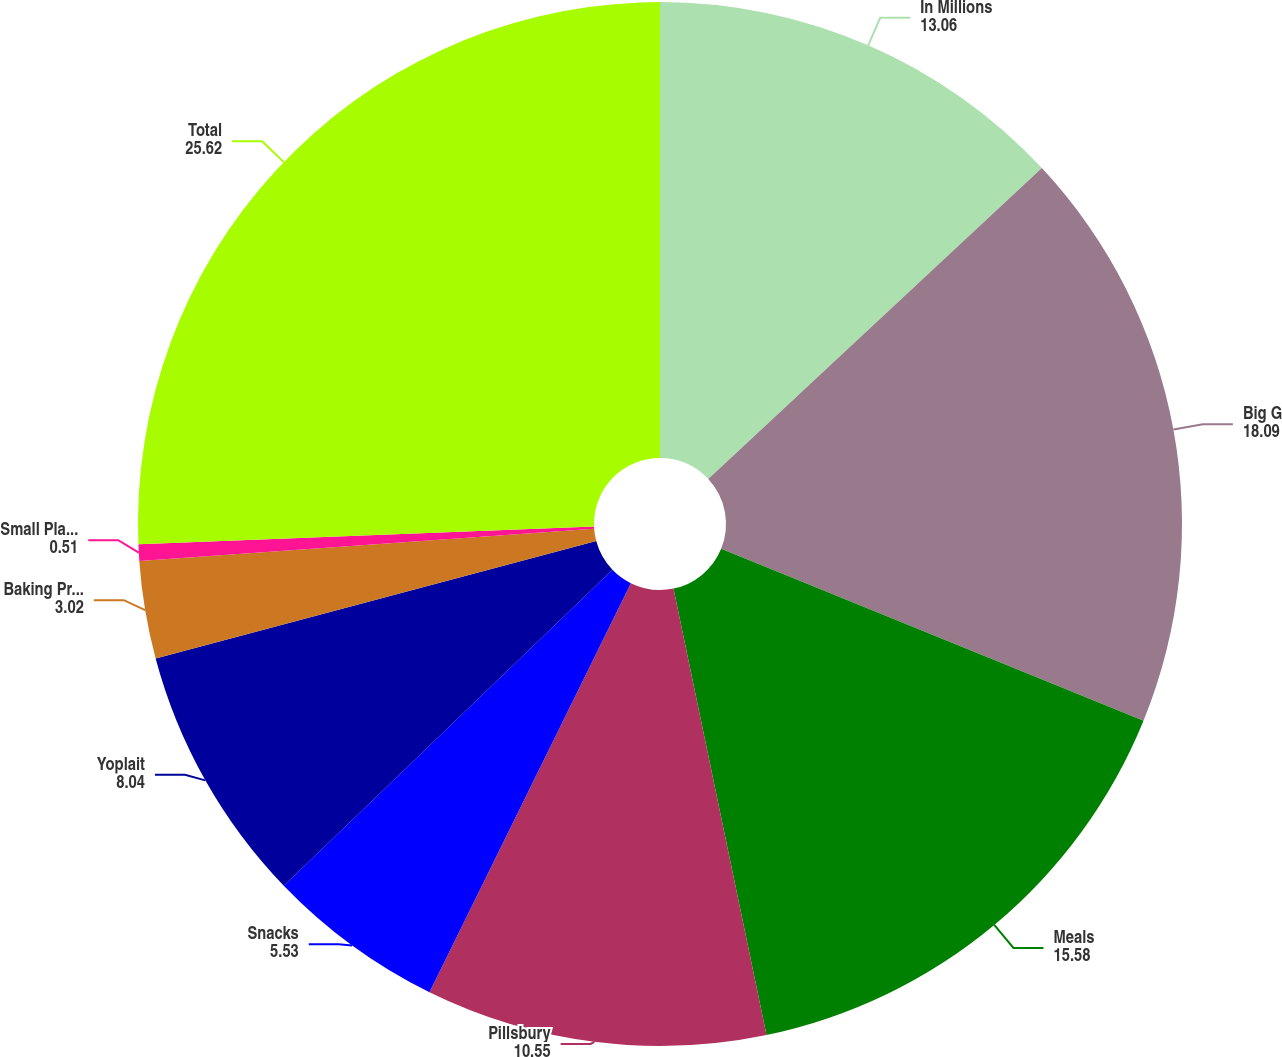Convert chart. <chart><loc_0><loc_0><loc_500><loc_500><pie_chart><fcel>In Millions<fcel>Big G<fcel>Meals<fcel>Pillsbury<fcel>Snacks<fcel>Yoplait<fcel>Baking Products<fcel>Small Planet Foods and other<fcel>Total<nl><fcel>13.06%<fcel>18.09%<fcel>15.58%<fcel>10.55%<fcel>5.53%<fcel>8.04%<fcel>3.02%<fcel>0.51%<fcel>25.62%<nl></chart> 